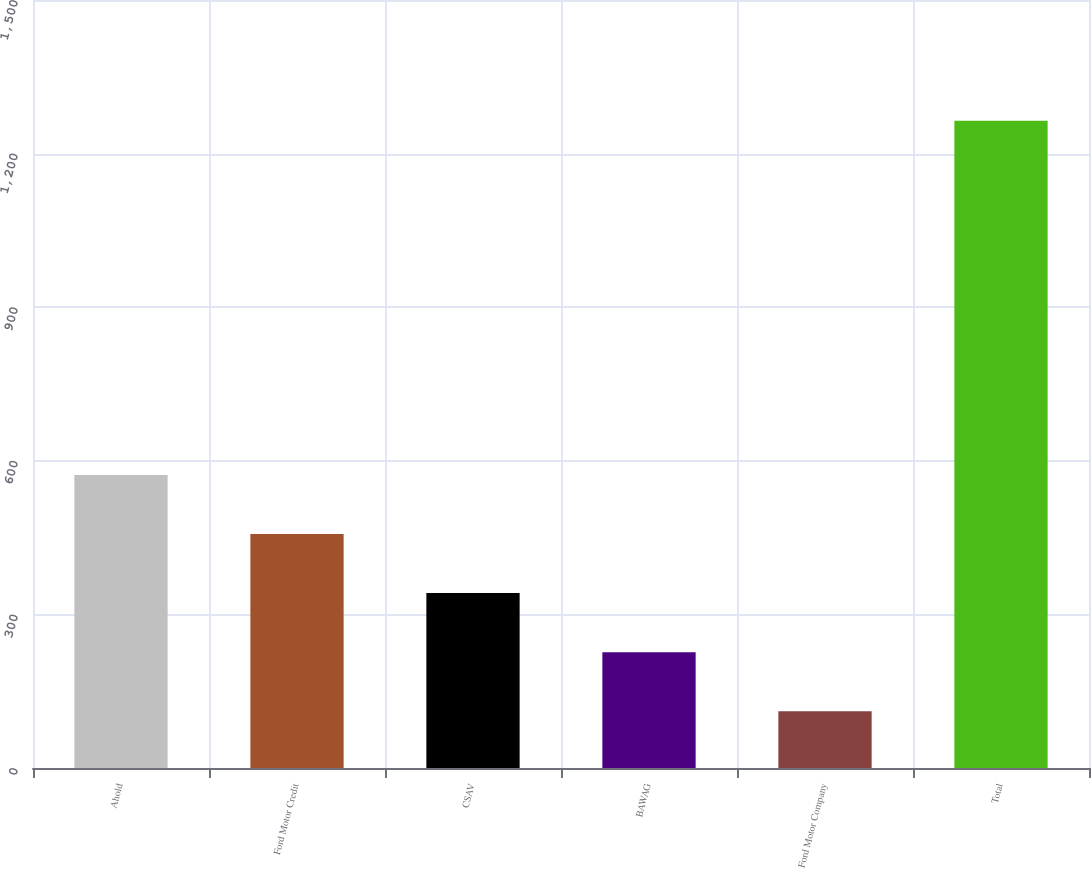Convert chart to OTSL. <chart><loc_0><loc_0><loc_500><loc_500><bar_chart><fcel>Ahold<fcel>Ford Motor Credit<fcel>CSAV<fcel>BAWAG<fcel>Ford Motor Company<fcel>Total<nl><fcel>572.2<fcel>456.9<fcel>341.6<fcel>226.3<fcel>111<fcel>1264<nl></chart> 